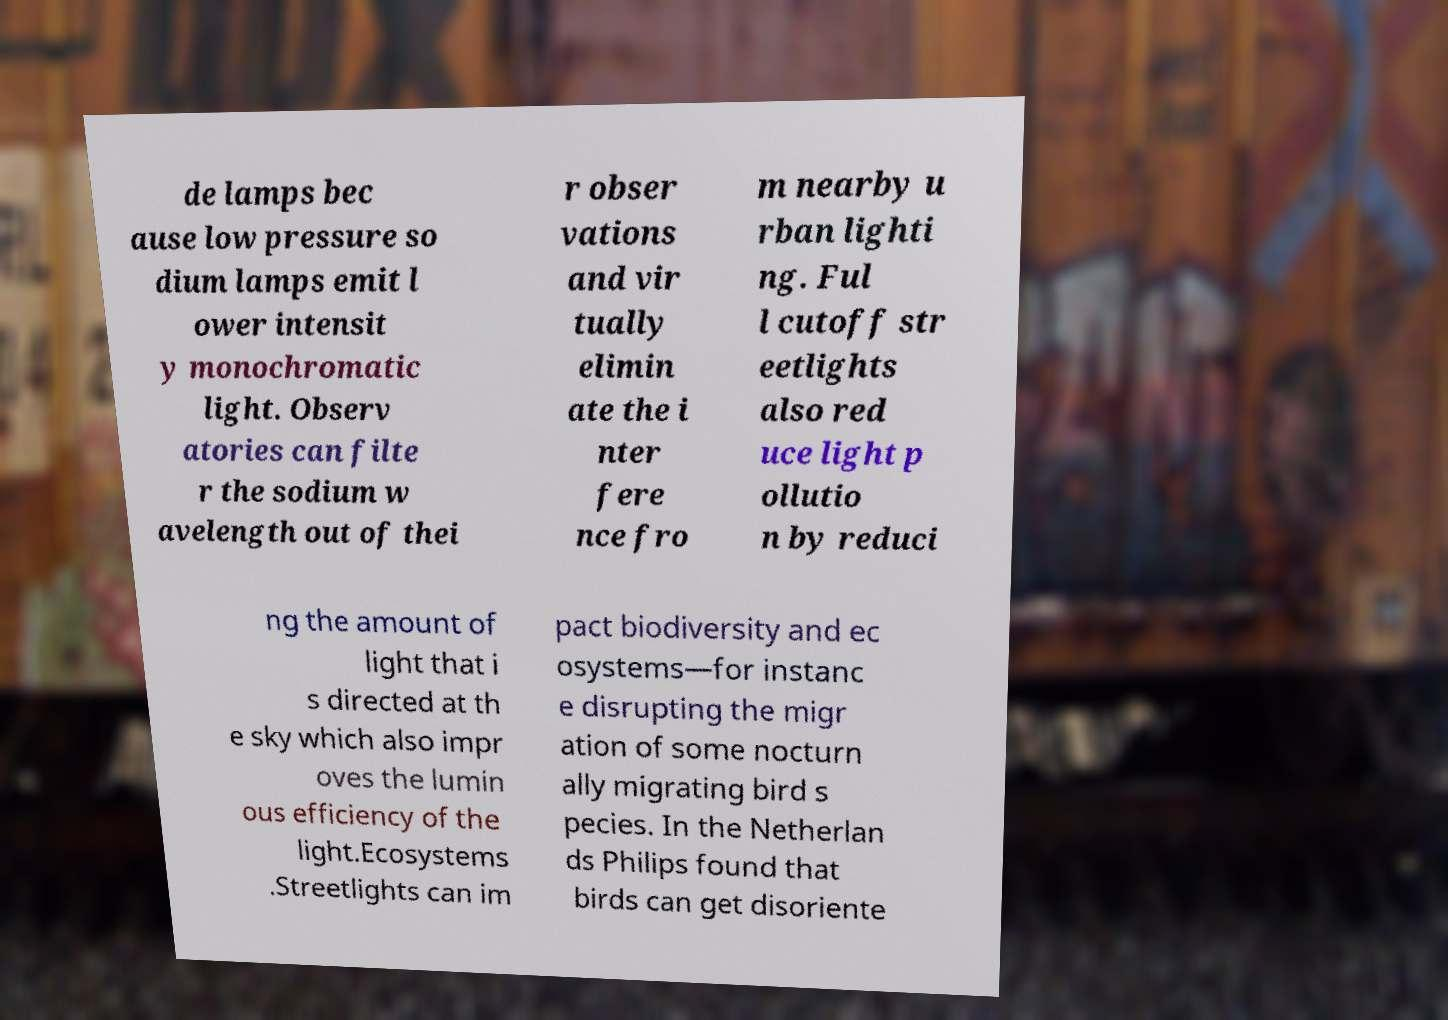For documentation purposes, I need the text within this image transcribed. Could you provide that? de lamps bec ause low pressure so dium lamps emit l ower intensit y monochromatic light. Observ atories can filte r the sodium w avelength out of thei r obser vations and vir tually elimin ate the i nter fere nce fro m nearby u rban lighti ng. Ful l cutoff str eetlights also red uce light p ollutio n by reduci ng the amount of light that i s directed at th e sky which also impr oves the lumin ous efficiency of the light.Ecosystems .Streetlights can im pact biodiversity and ec osystems—for instanc e disrupting the migr ation of some nocturn ally migrating bird s pecies. In the Netherlan ds Philips found that birds can get disoriente 